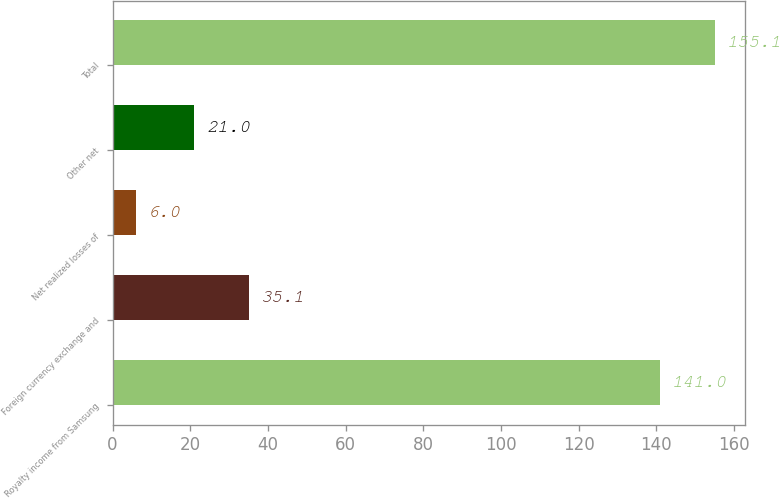Convert chart. <chart><loc_0><loc_0><loc_500><loc_500><bar_chart><fcel>Royalty income from Samsung<fcel>Foreign currency exchange and<fcel>Net realized losses of<fcel>Other net<fcel>Total<nl><fcel>141<fcel>35.1<fcel>6<fcel>21<fcel>155.1<nl></chart> 